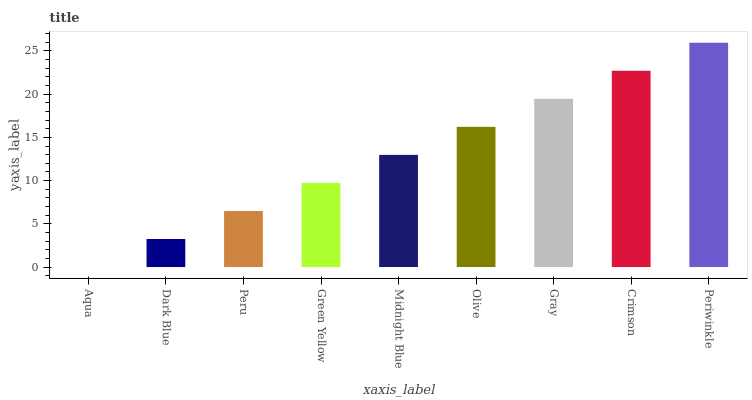Is Aqua the minimum?
Answer yes or no. Yes. Is Periwinkle the maximum?
Answer yes or no. Yes. Is Dark Blue the minimum?
Answer yes or no. No. Is Dark Blue the maximum?
Answer yes or no. No. Is Dark Blue greater than Aqua?
Answer yes or no. Yes. Is Aqua less than Dark Blue?
Answer yes or no. Yes. Is Aqua greater than Dark Blue?
Answer yes or no. No. Is Dark Blue less than Aqua?
Answer yes or no. No. Is Midnight Blue the high median?
Answer yes or no. Yes. Is Midnight Blue the low median?
Answer yes or no. Yes. Is Peru the high median?
Answer yes or no. No. Is Dark Blue the low median?
Answer yes or no. No. 